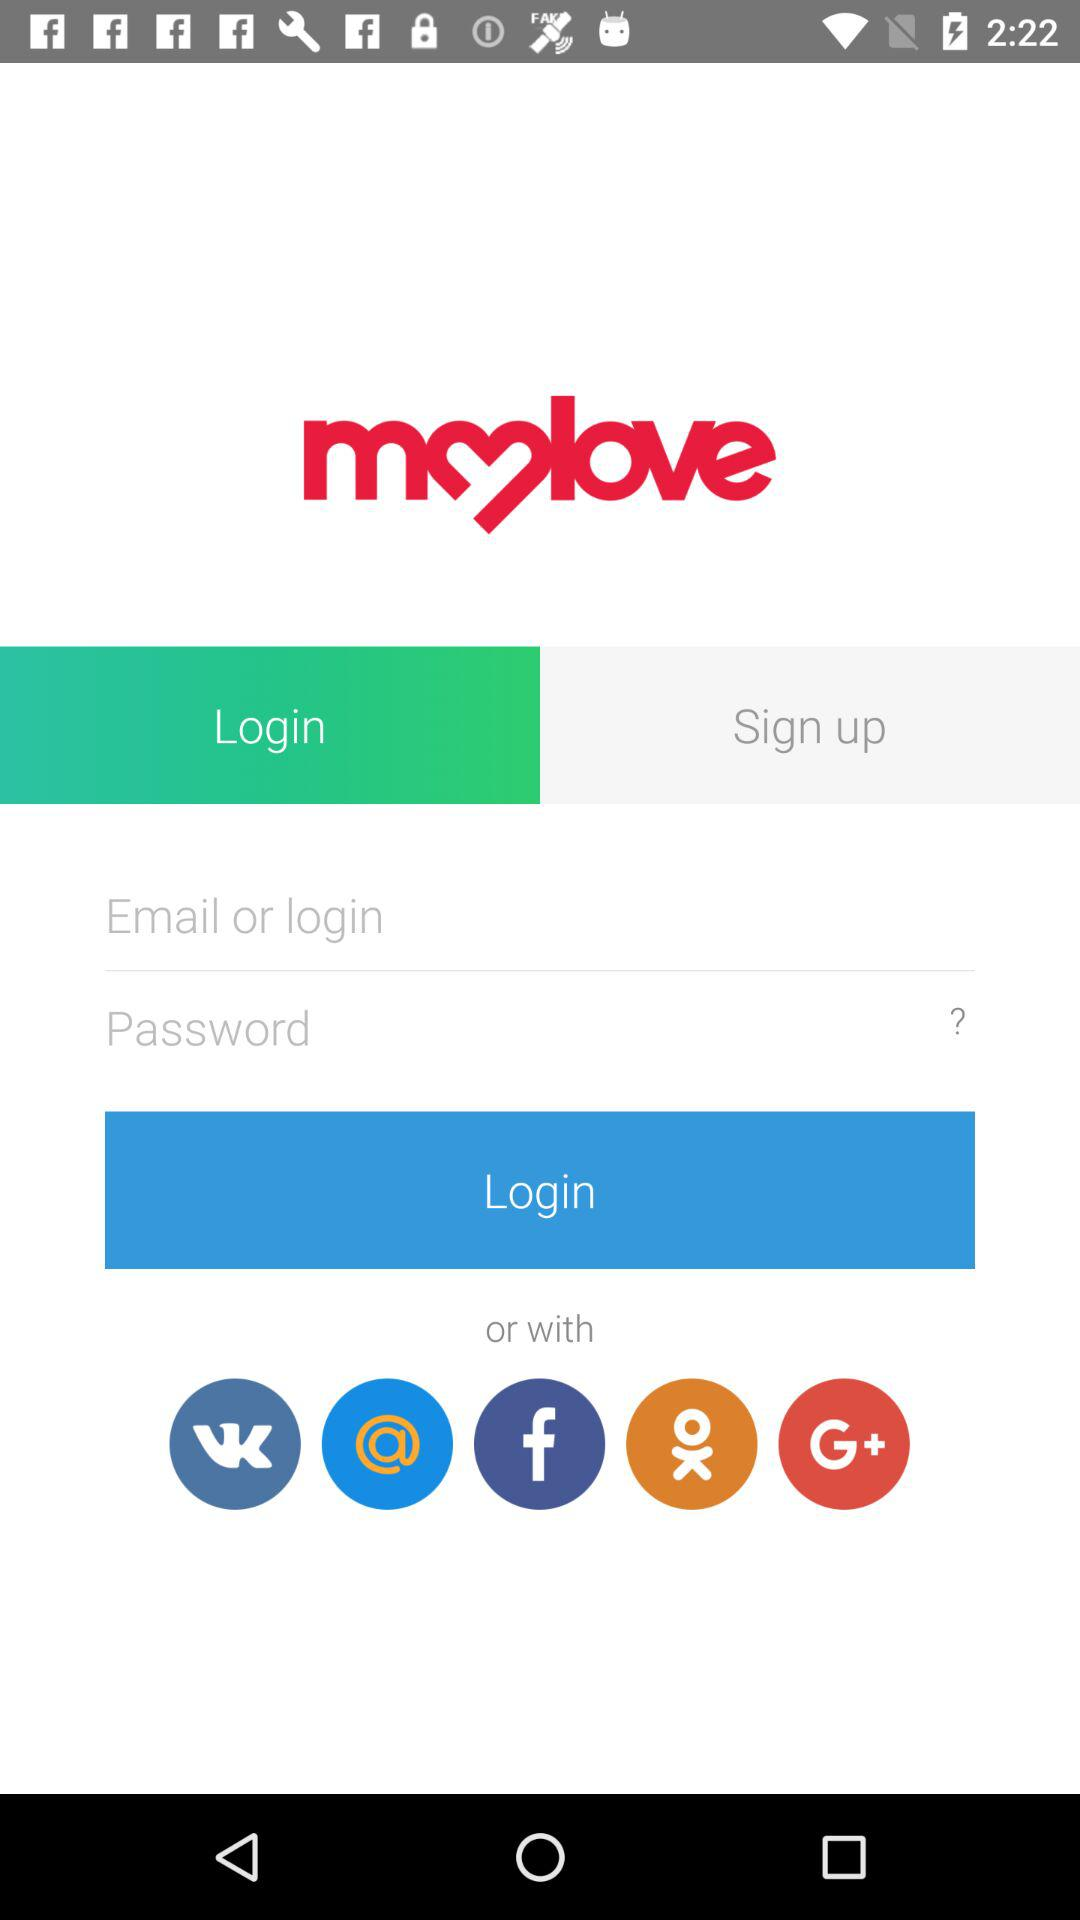Through which application can log in be done? Log in can be done through "VK", "Mail", "Facebook", "OK" and "Google+". 